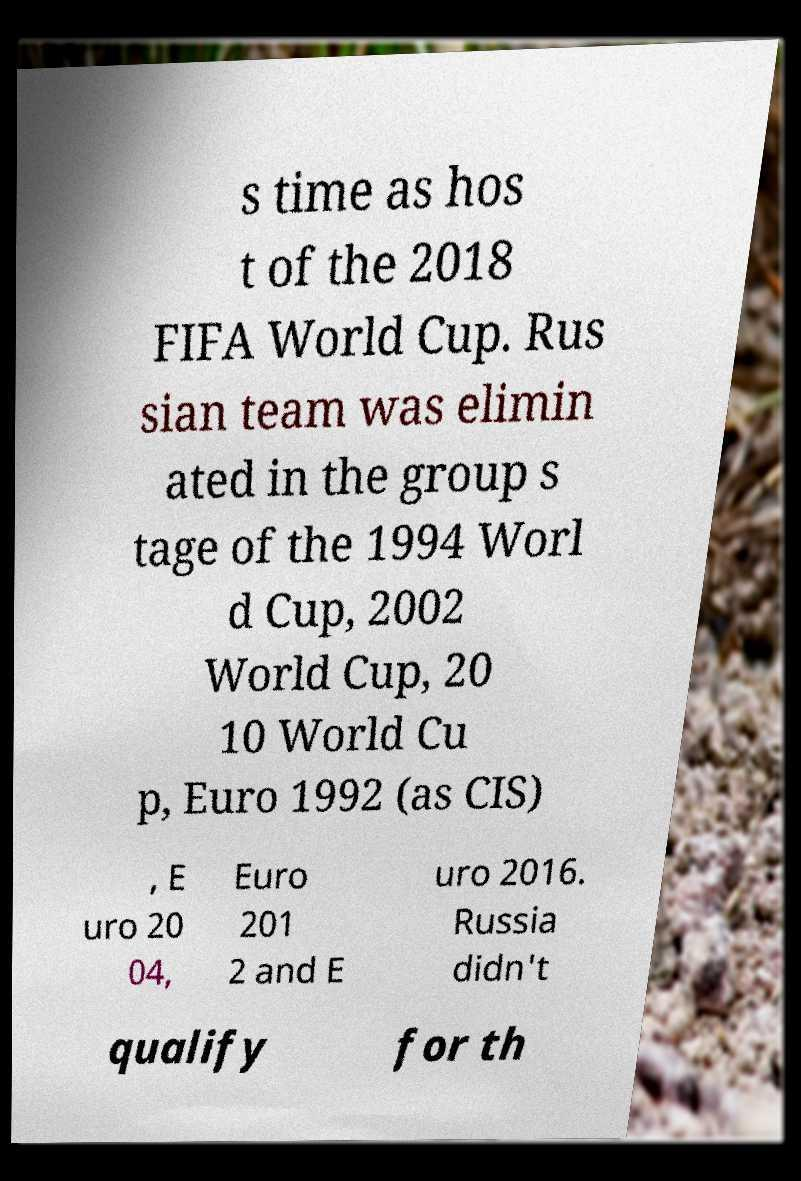Could you extract and type out the text from this image? s time as hos t of the 2018 FIFA World Cup. Rus sian team was elimin ated in the group s tage of the 1994 Worl d Cup, 2002 World Cup, 20 10 World Cu p, Euro 1992 (as CIS) , E uro 20 04, Euro 201 2 and E uro 2016. Russia didn't qualify for th 